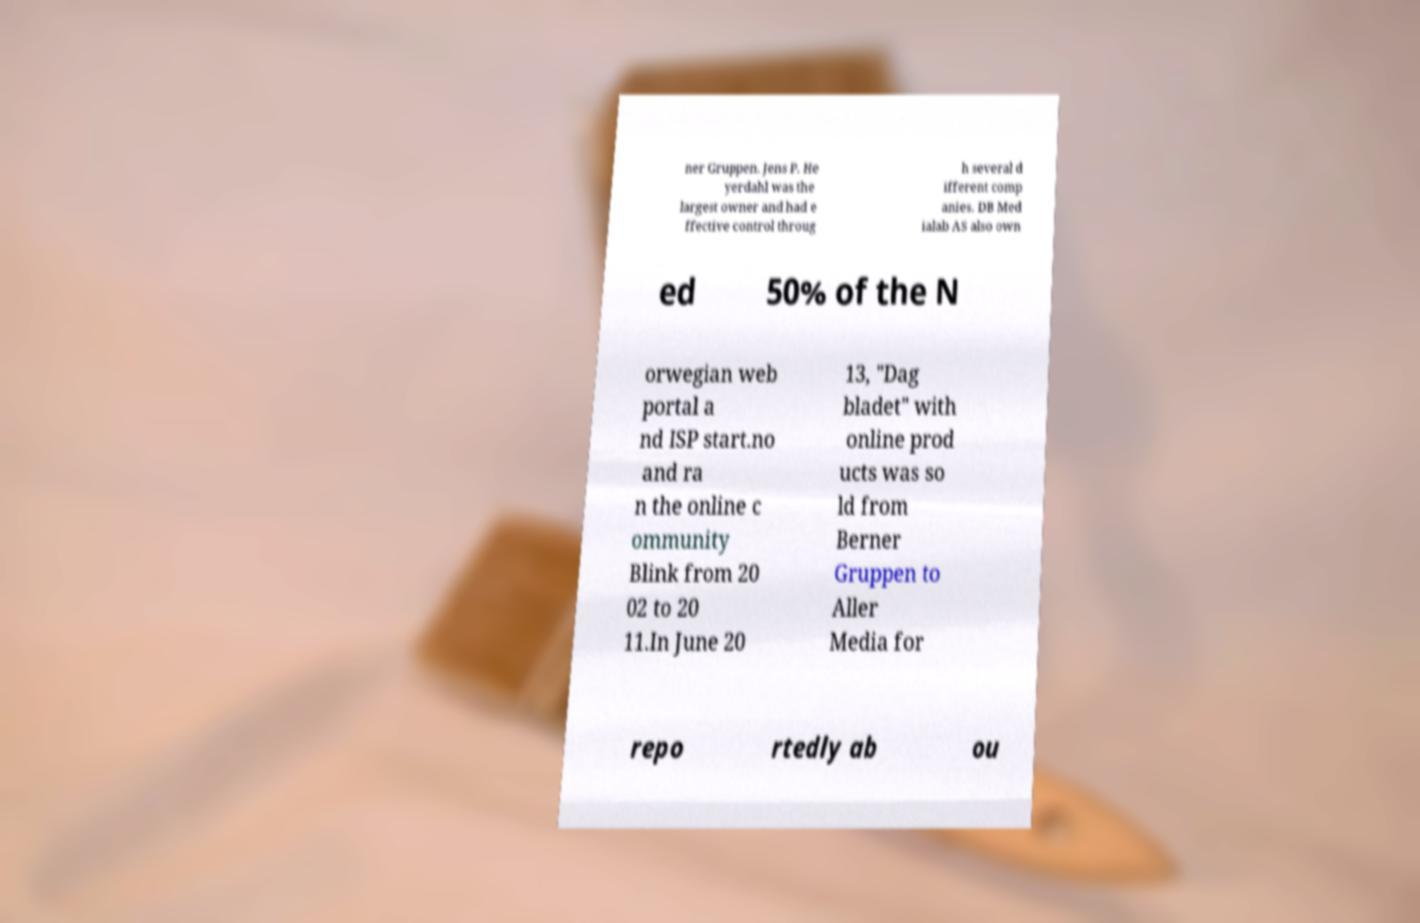Please identify and transcribe the text found in this image. ner Gruppen. Jens P. He yerdahl was the largest owner and had e ffective control throug h several d ifferent comp anies. DB Med ialab AS also own ed 50% of the N orwegian web portal a nd ISP start.no and ra n the online c ommunity Blink from 20 02 to 20 11.In June 20 13, "Dag bladet" with online prod ucts was so ld from Berner Gruppen to Aller Media for repo rtedly ab ou 